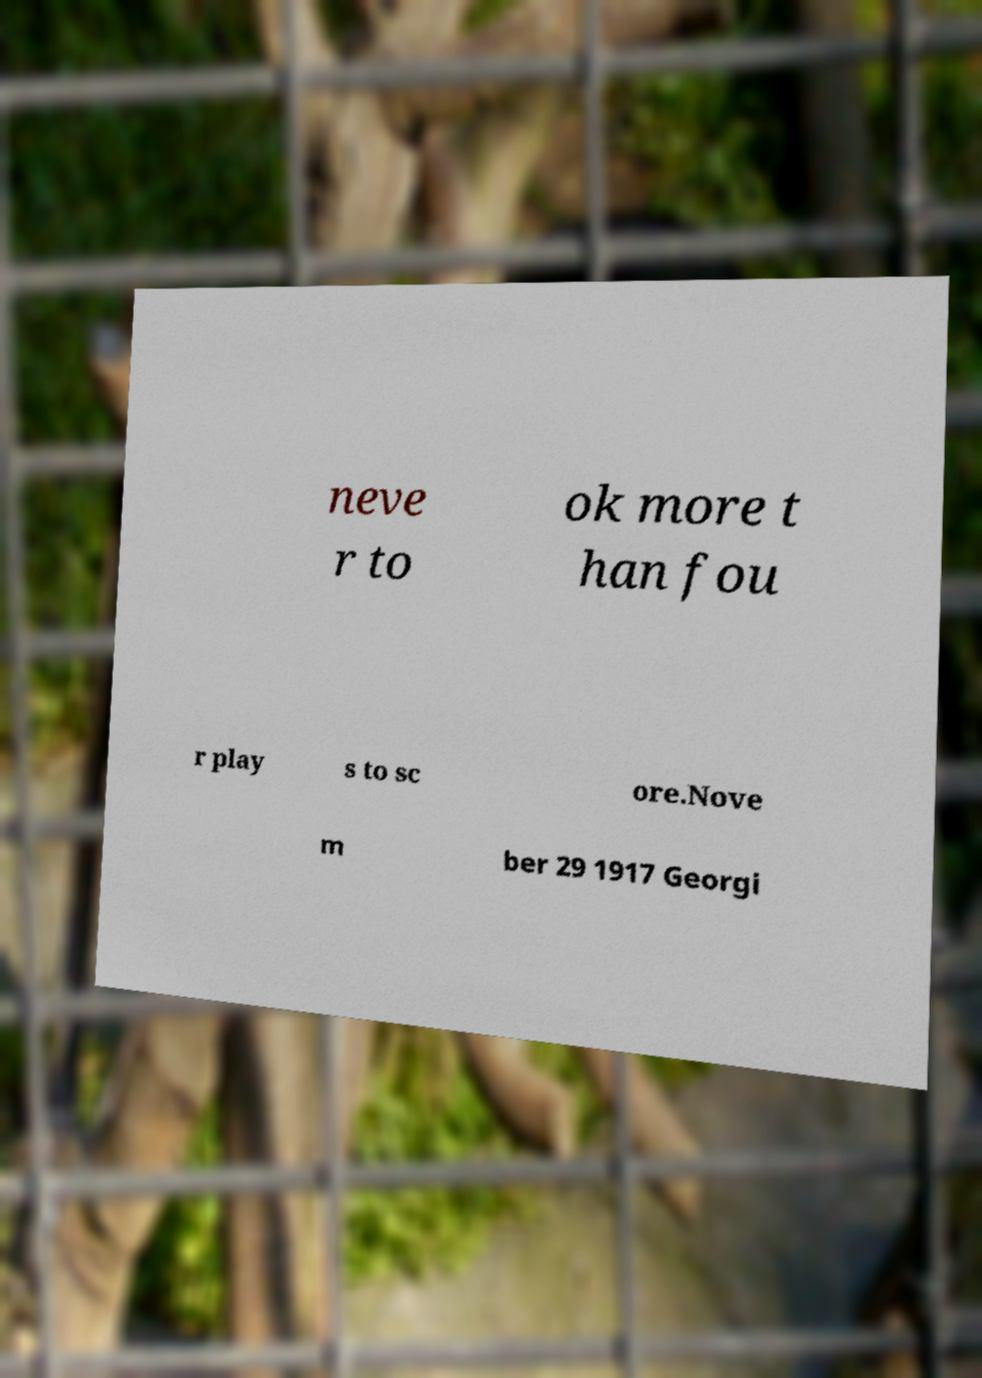There's text embedded in this image that I need extracted. Can you transcribe it verbatim? neve r to ok more t han fou r play s to sc ore.Nove m ber 29 1917 Georgi 